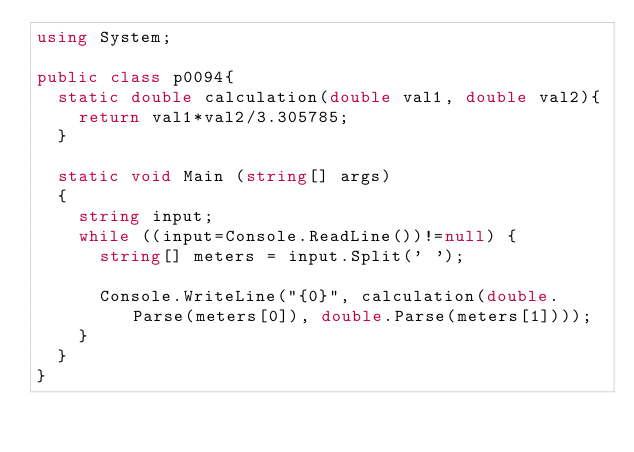Convert code to text. <code><loc_0><loc_0><loc_500><loc_500><_C#_>using System;

public class p0094{
	static double calculation(double val1, double val2){
		return val1*val2/3.305785;
	}

	static void Main (string[] args)
	{
		string input;
		while ((input=Console.ReadLine())!=null) {
			string[] meters = input.Split(' ');

			Console.WriteLine("{0}", calculation(double.Parse(meters[0]), double.Parse(meters[1])));
		}
	}
}</code> 